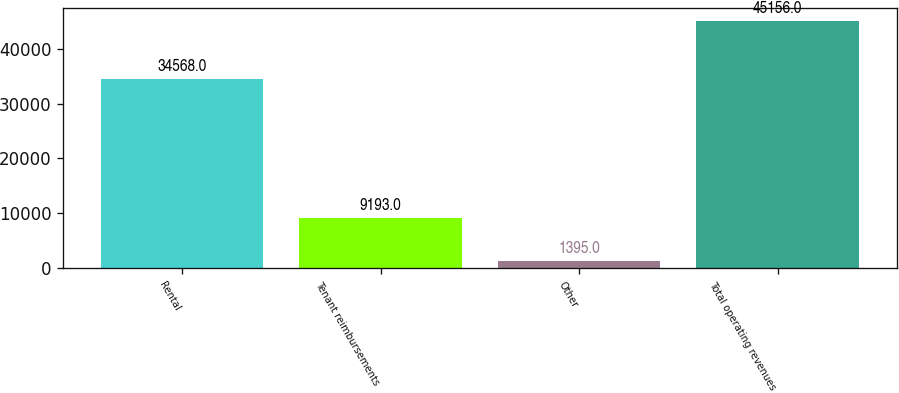Convert chart. <chart><loc_0><loc_0><loc_500><loc_500><bar_chart><fcel>Rental<fcel>Tenant reimbursements<fcel>Other<fcel>Total operating revenues<nl><fcel>34568<fcel>9193<fcel>1395<fcel>45156<nl></chart> 